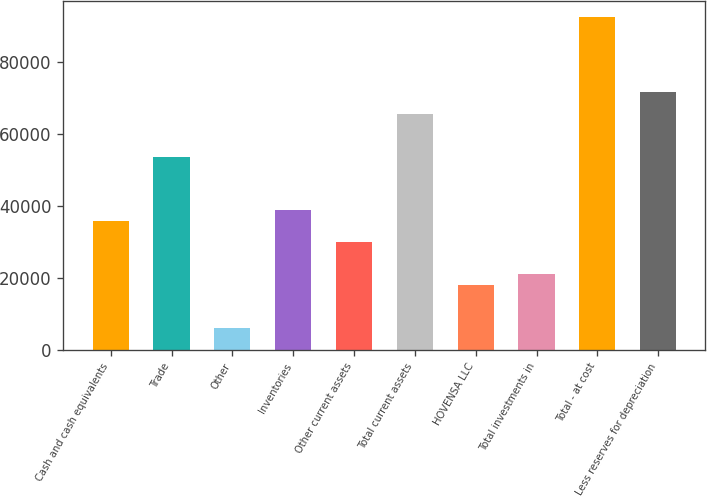Convert chart to OTSL. <chart><loc_0><loc_0><loc_500><loc_500><bar_chart><fcel>Cash and cash equivalents<fcel>Trade<fcel>Other<fcel>Inventories<fcel>Other current assets<fcel>Total current assets<fcel>HOVENSA LLC<fcel>Total investments in<fcel>Total - at cost<fcel>Less reserves for depreciation<nl><fcel>35816.4<fcel>53652.6<fcel>6089.4<fcel>38789.1<fcel>29871<fcel>65543.4<fcel>17980.2<fcel>20952.9<fcel>92297.7<fcel>71488.8<nl></chart> 